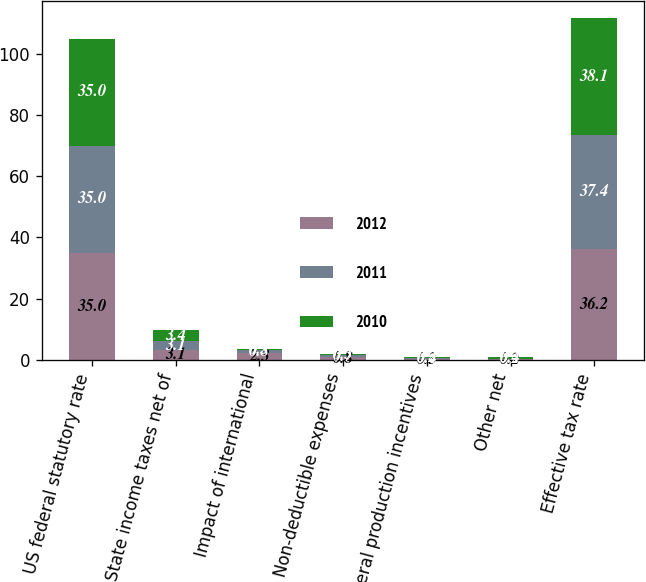Convert chart to OTSL. <chart><loc_0><loc_0><loc_500><loc_500><stacked_bar_chart><ecel><fcel>US federal statutory rate<fcel>State income taxes net of<fcel>Impact of international<fcel>Non-deductible expenses<fcel>Federal production incentives<fcel>Other net<fcel>Effective tax rate<nl><fcel>2012<fcel>35<fcel>3.1<fcel>2.3<fcel>0.8<fcel>0.3<fcel>0.2<fcel>36.2<nl><fcel>2011<fcel>35<fcel>3.1<fcel>0.8<fcel>0.7<fcel>0.4<fcel>0.2<fcel>37.4<nl><fcel>2010<fcel>35<fcel>3.4<fcel>0.3<fcel>0.3<fcel>0.2<fcel>0.4<fcel>38.1<nl></chart> 